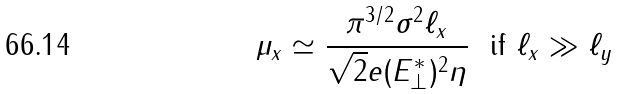Convert formula to latex. <formula><loc_0><loc_0><loc_500><loc_500>\mu _ { x } \simeq \frac { \pi ^ { 3 / 2 } \sigma ^ { 2 } \ell _ { x } } { \sqrt { 2 } e ( E _ { \perp } ^ { * } ) ^ { 2 } \eta } \ \text { if } \ell _ { x } \gg \ell _ { y }</formula> 